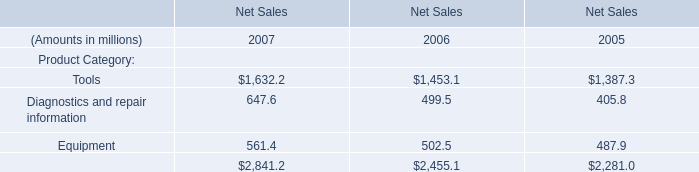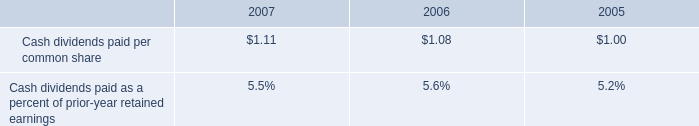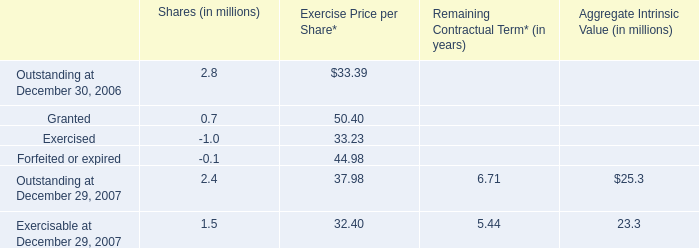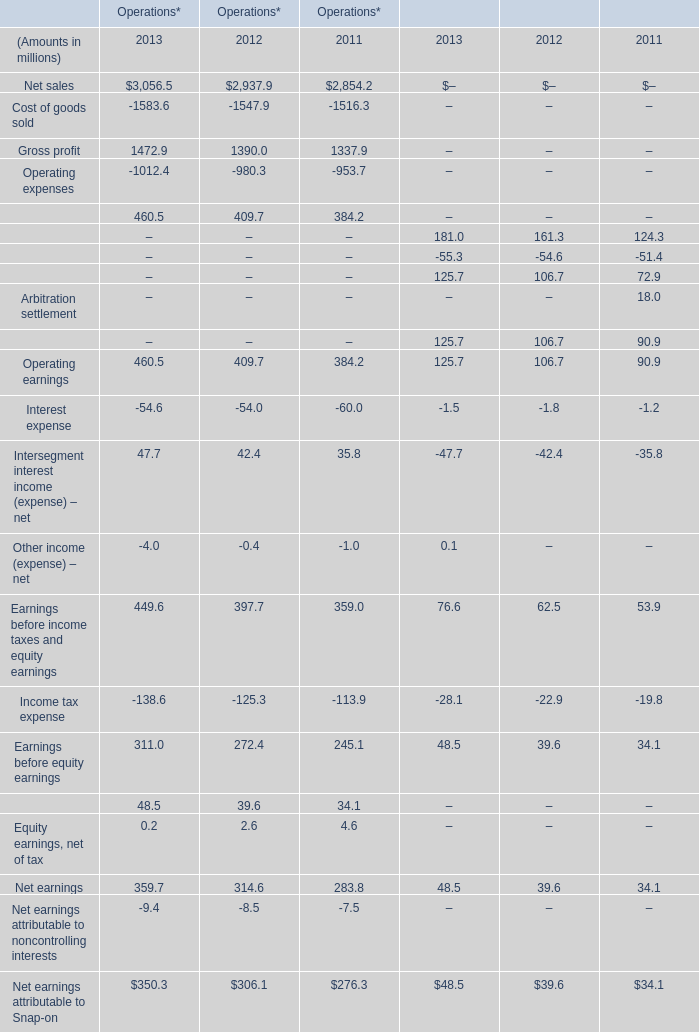What will Financial services revenue for financial services reach in 2013 if it continues to grow at its current rate? (in million) 
Computations: ((((181 - 161.3) / 161.3) + 1) * 181)
Answer: 203.10601. 